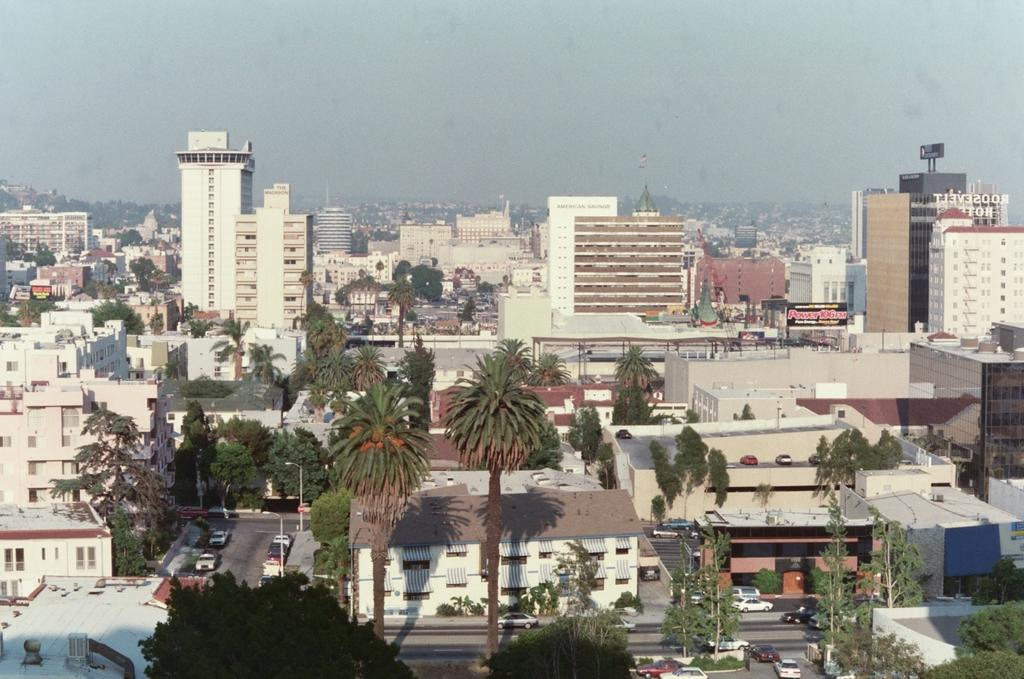What type of natural elements can be seen in the image? There are trees in the image. What type of man-made structures are present in the image? There are buildings in the image. What type of transportation is visible in the image? There are vehicles in the image. How would you describe the weather in the image? The sky is cloudy in the image. What type of leather is being used to make the insects fly in the image? There are no insects or leather present in the image. How many buildings are made of leather in the image? There are no buildings made of leather in the image. 